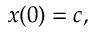<formula> <loc_0><loc_0><loc_500><loc_500>x ( 0 ) = c ,</formula> 